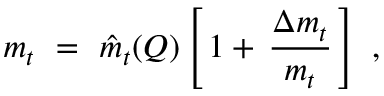<formula> <loc_0><loc_0><loc_500><loc_500>m _ { t } \ = \ \hat { m } _ { t } ( Q ) \left [ \, 1 + \, { \frac { \Delta m _ { t } } { m _ { t } } } \, \right ] \ ,</formula> 